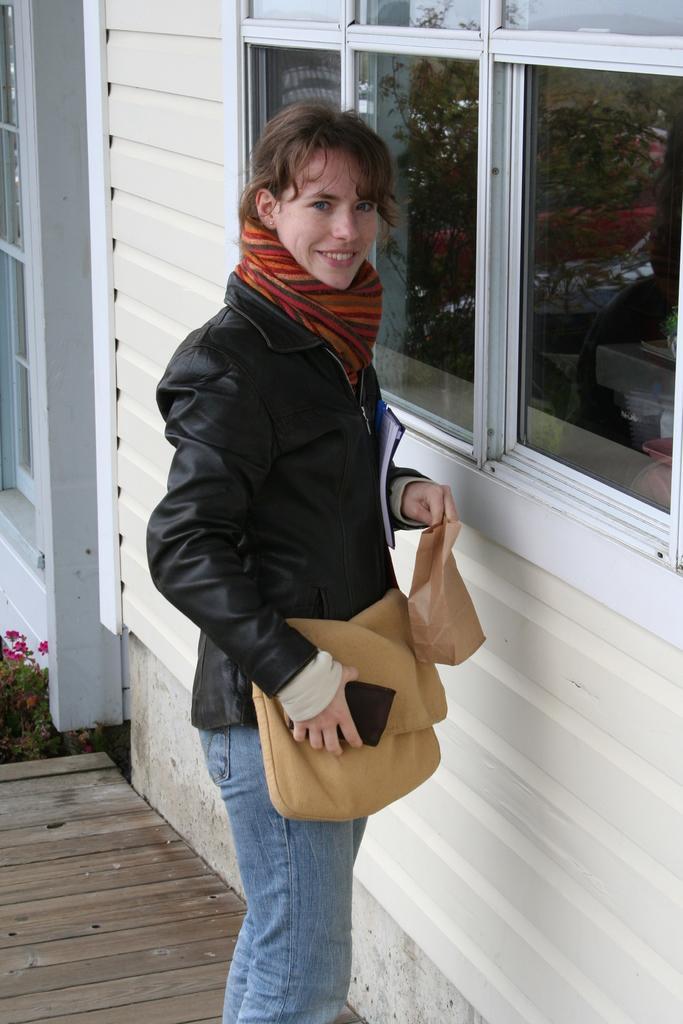In one or two sentences, can you explain what this image depicts? In this picture I can observe a woman. She is wearing a jacket. The woman is smiling. In front of her there are windows. 